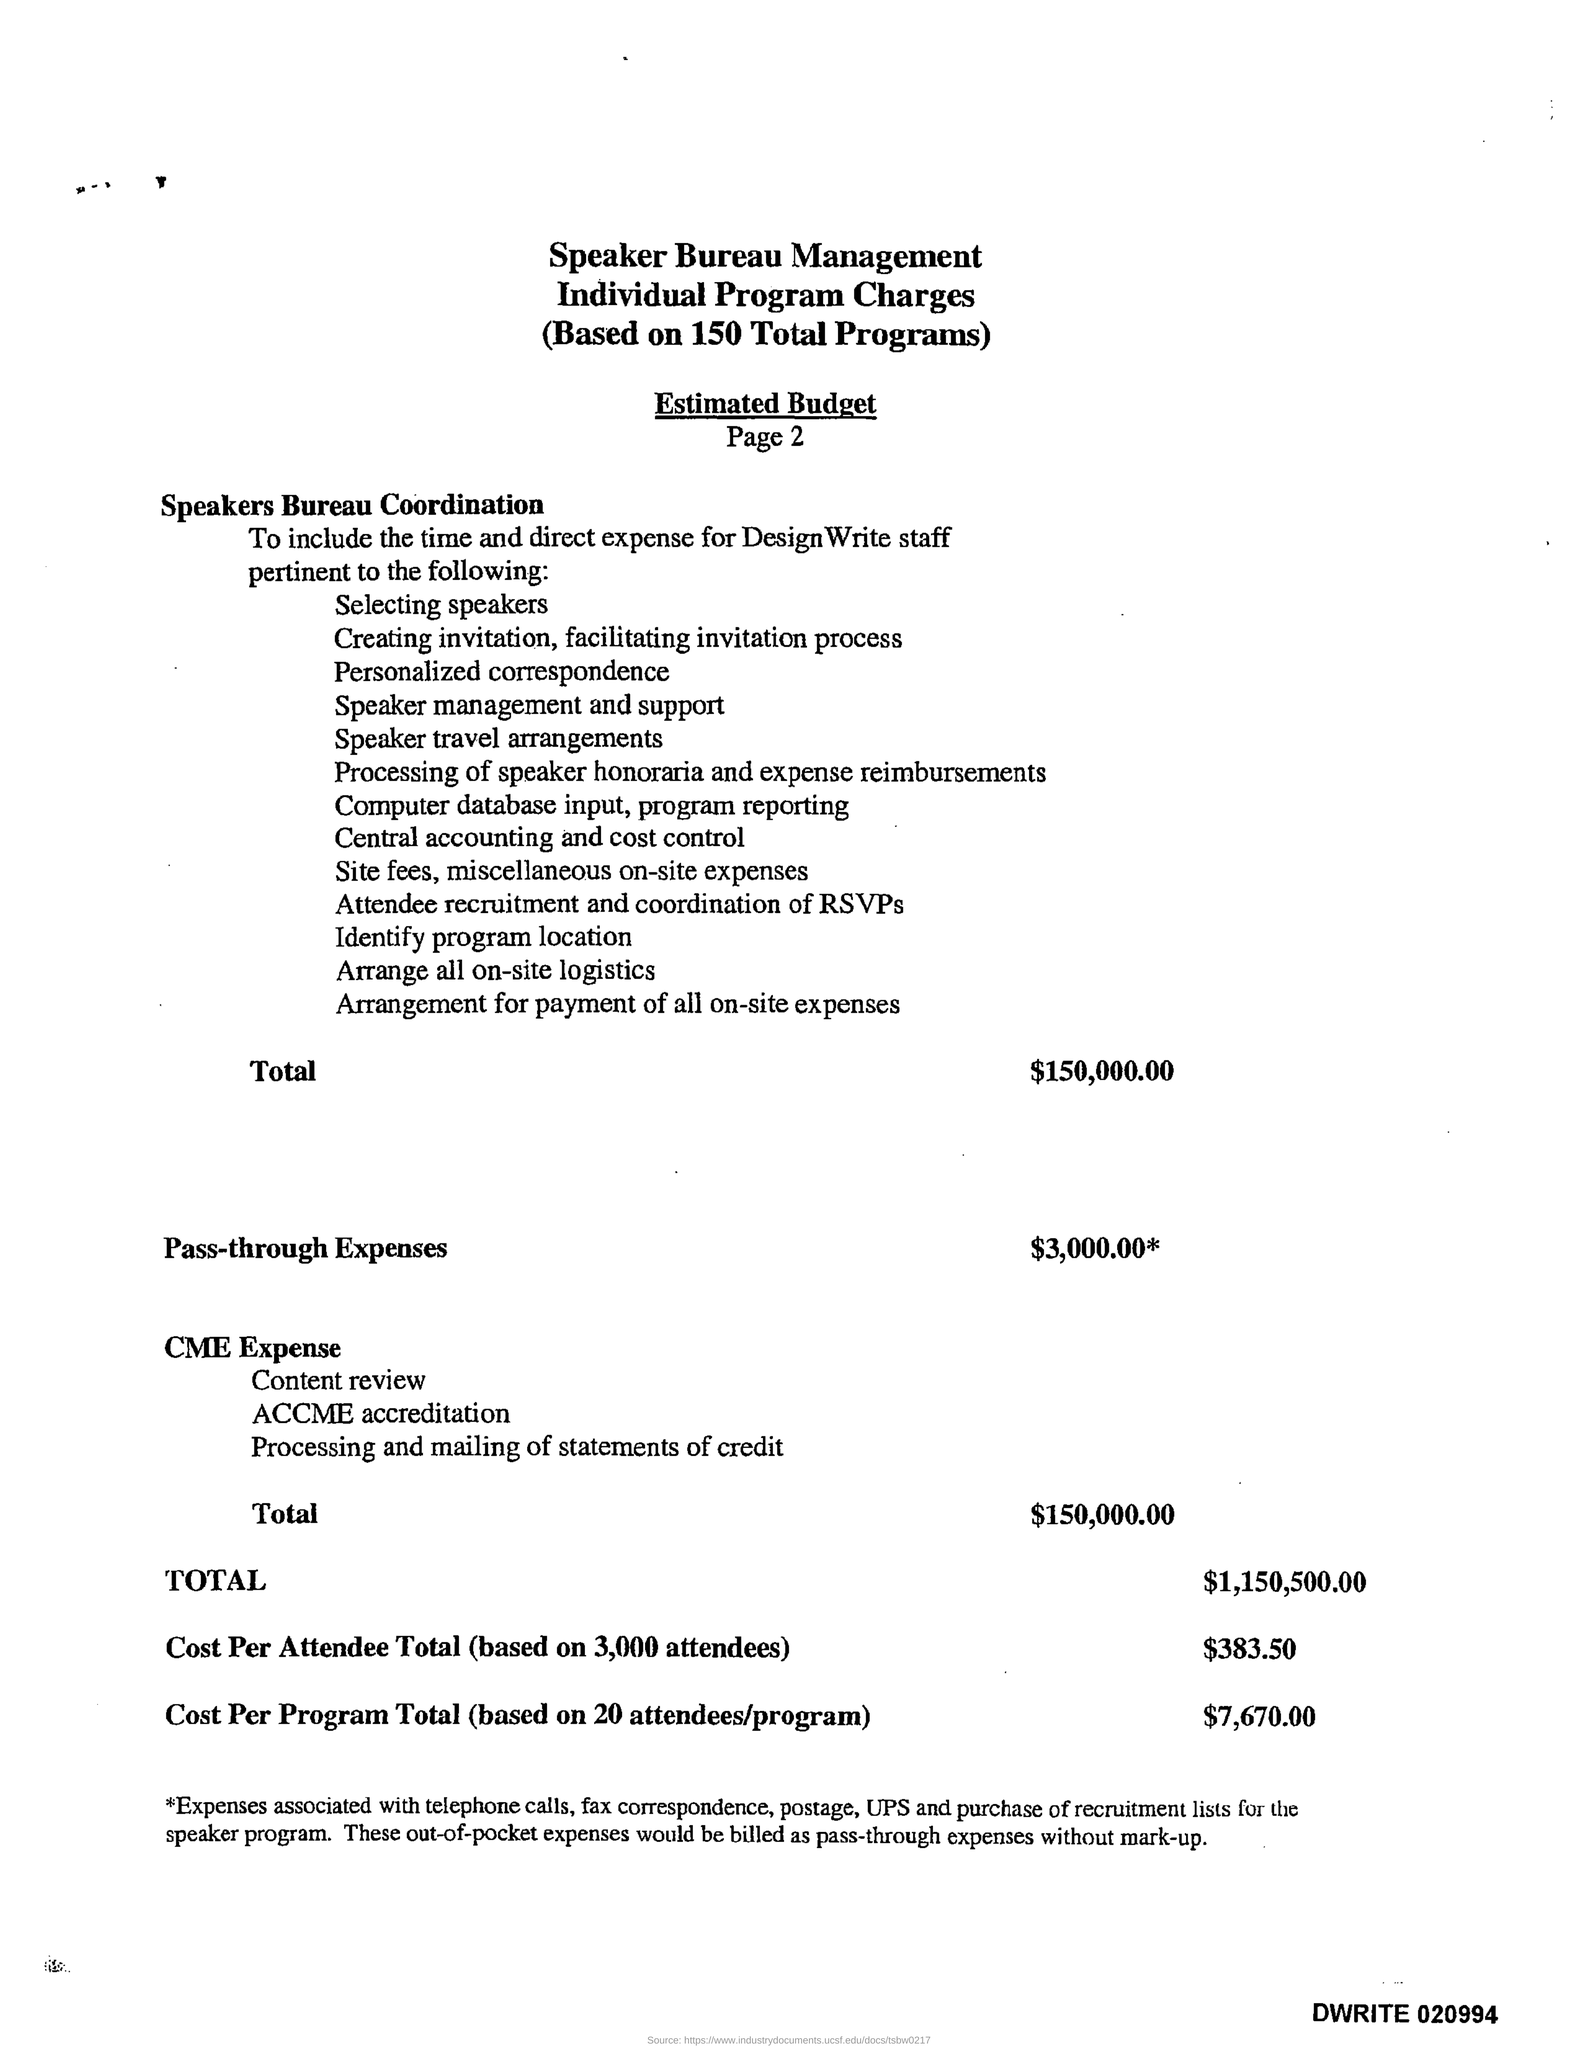What is the Total Estimated Budget for Speakers Bureau Coordination?
Your answer should be compact. 150,000.00. What is the Estimated Budget for Pass-through Expenses?
Give a very brief answer. $3,000.00*. What is the Total Budget Estimate for CME Expense?
Offer a terse response. 150,000.00. What is the Cost Per Attendee Total (based on 3,000 attendees)?
Your answer should be compact. $383.50. What is the Cost Per Program Total (based on 20 attendees/program)?
Your response must be concise. $7,670.00. 